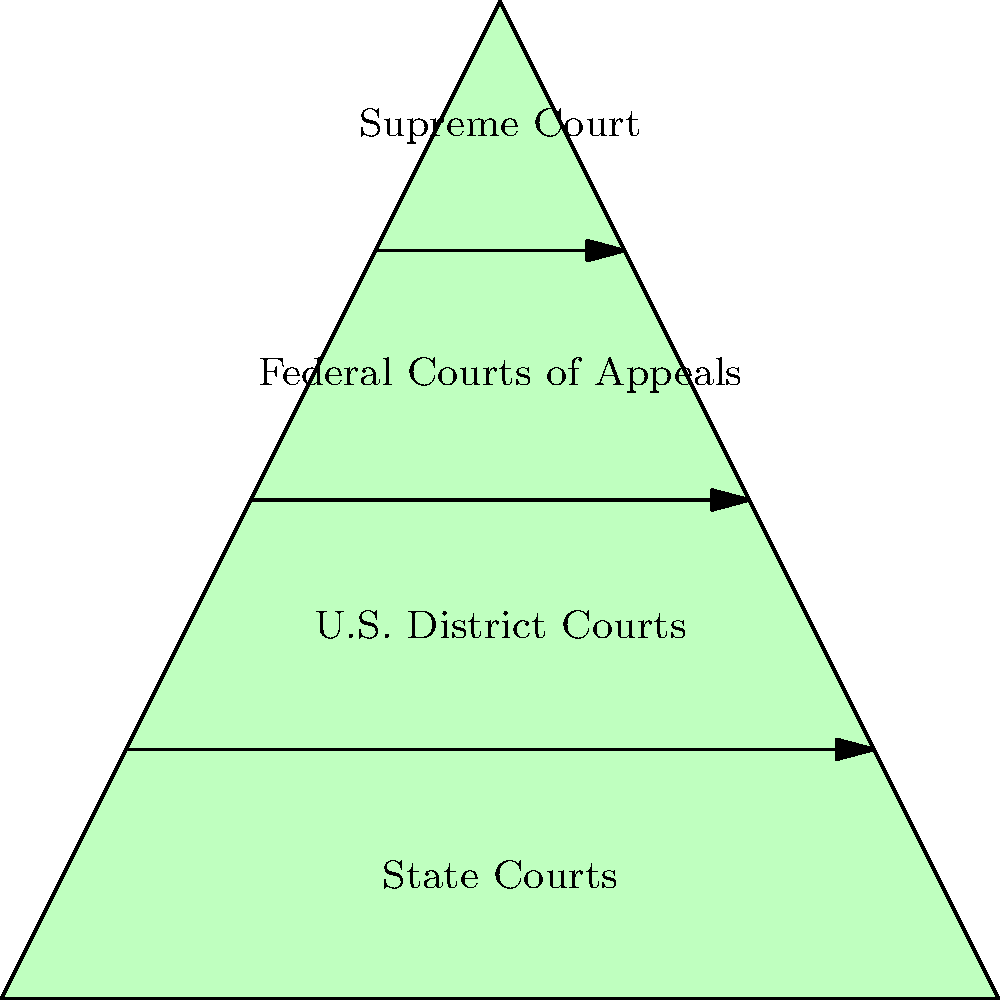As someone who has experienced the judicial system firsthand, you understand the importance of court hierarchy. In the pyramid structure shown above, which level of courts would typically handle a federal criminal case in the first instance? To answer this question, let's break down the structure of the federal judicial system as shown in the pyramid:

1. At the top of the pyramid is the Supreme Court, which is the highest court in the United States.
2. Below that are the Federal Courts of Appeals, also known as Circuit Courts.
3. The next level down shows the U.S. District Courts.
4. At the bottom are State Courts, which are separate from the federal system.

For federal criminal cases:

1. These cases are handled by the federal court system, not state courts.
2. The court of first instance (where a case is first tried) in the federal system is the U.S. District Court.
3. Federal Courts of Appeals and the Supreme Court typically handle appeals, not initial trials.

Therefore, a federal criminal case would typically start at the U.S. District Court level.
Answer: U.S. District Courts 